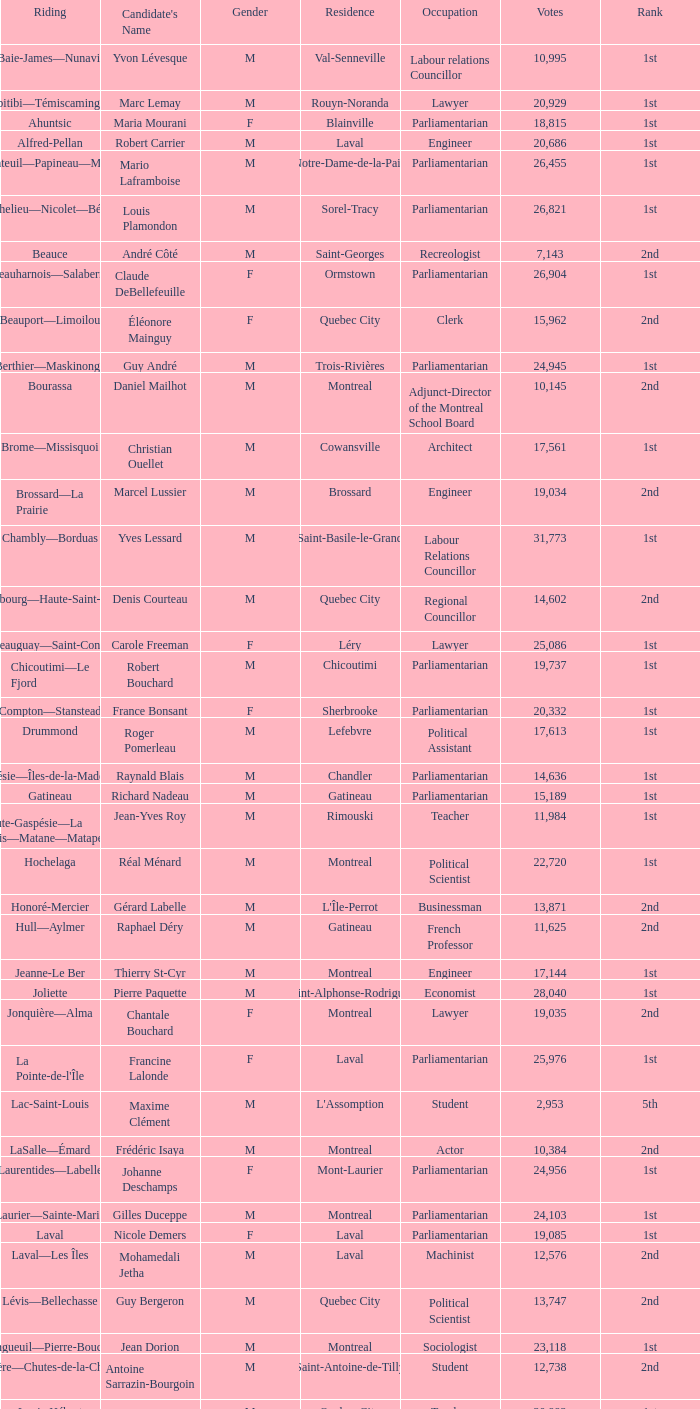What is the greatest amount of votes the french professor has obtained? 11625.0. 